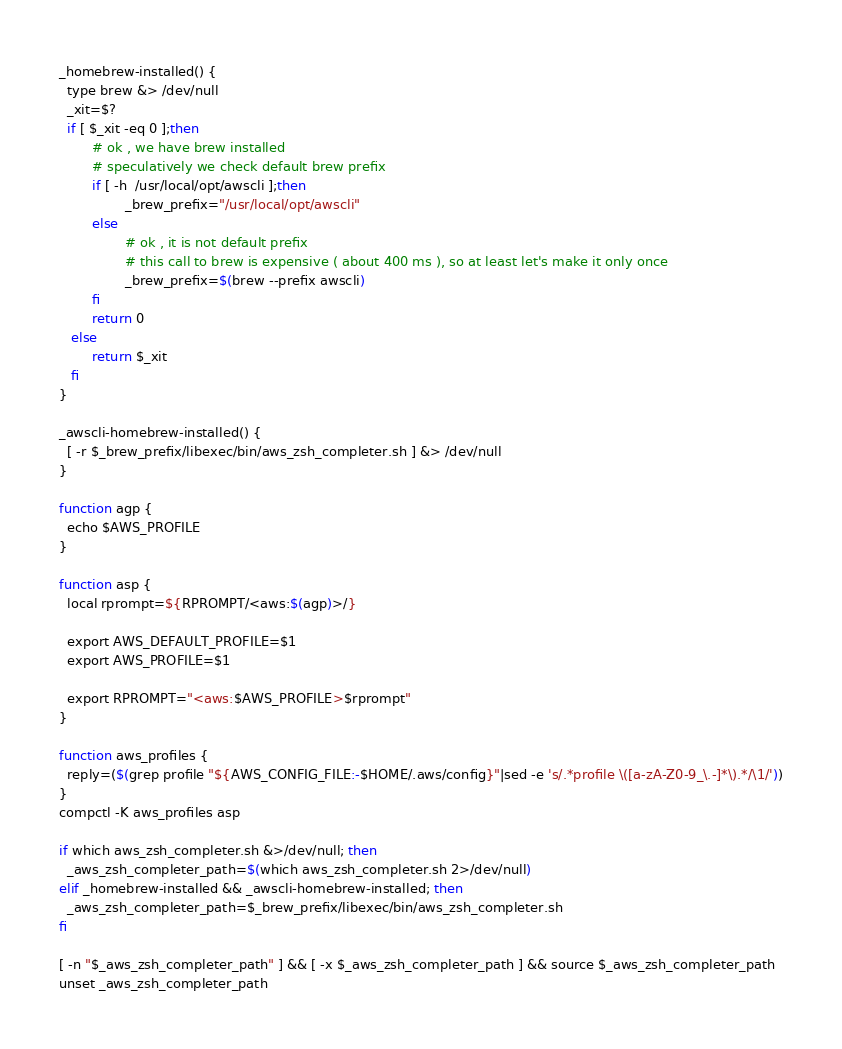<code> <loc_0><loc_0><loc_500><loc_500><_Bash_>_homebrew-installed() {
  type brew &> /dev/null
  _xit=$?
  if [ $_xit -eq 0 ];then
        # ok , we have brew installed
        # speculatively we check default brew prefix
        if [ -h  /usr/local/opt/awscli ];then
                _brew_prefix="/usr/local/opt/awscli"
        else
                # ok , it is not default prefix
                # this call to brew is expensive ( about 400 ms ), so at least let's make it only once
                _brew_prefix=$(brew --prefix awscli)
        fi
        return 0
   else
        return $_xit
   fi
}

_awscli-homebrew-installed() {
  [ -r $_brew_prefix/libexec/bin/aws_zsh_completer.sh ] &> /dev/null
}

function agp {
  echo $AWS_PROFILE
}

function asp {
  local rprompt=${RPROMPT/<aws:$(agp)>/}

  export AWS_DEFAULT_PROFILE=$1
  export AWS_PROFILE=$1

  export RPROMPT="<aws:$AWS_PROFILE>$rprompt"
}

function aws_profiles {
  reply=($(grep profile "${AWS_CONFIG_FILE:-$HOME/.aws/config}"|sed -e 's/.*profile \([a-zA-Z0-9_\.-]*\).*/\1/'))
}
compctl -K aws_profiles asp

if which aws_zsh_completer.sh &>/dev/null; then
  _aws_zsh_completer_path=$(which aws_zsh_completer.sh 2>/dev/null)
elif _homebrew-installed && _awscli-homebrew-installed; then
  _aws_zsh_completer_path=$_brew_prefix/libexec/bin/aws_zsh_completer.sh
fi

[ -n "$_aws_zsh_completer_path" ] && [ -x $_aws_zsh_completer_path ] && source $_aws_zsh_completer_path
unset _aws_zsh_completer_path
</code> 